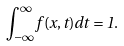<formula> <loc_0><loc_0><loc_500><loc_500>\int _ { - \infty } ^ { \infty } f ( x , t ) d t = 1 .</formula> 